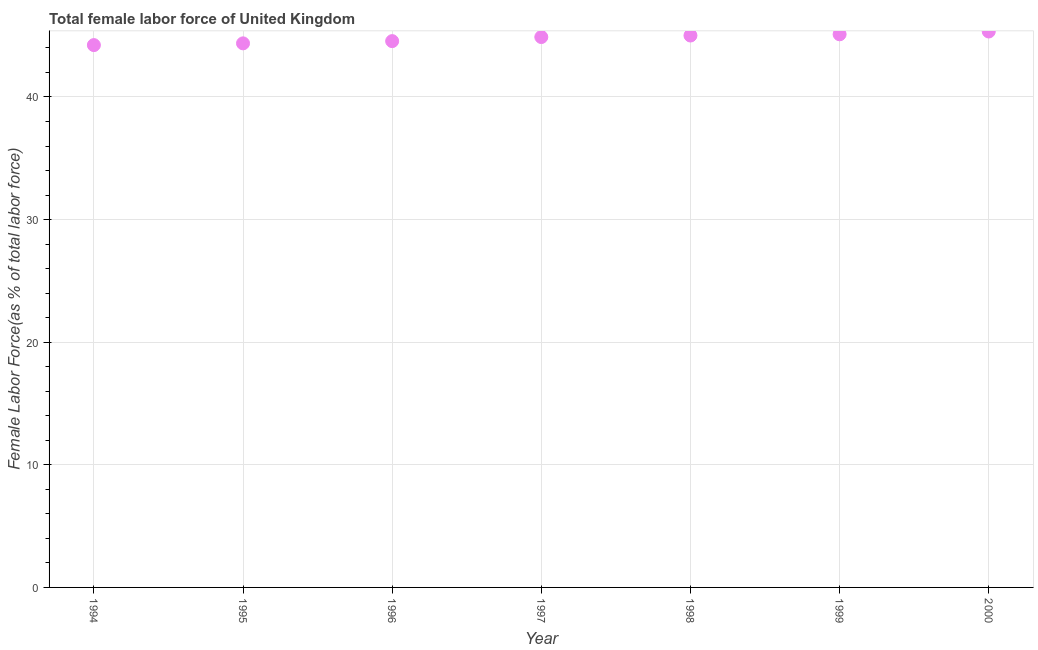What is the total female labor force in 1994?
Give a very brief answer. 44.23. Across all years, what is the maximum total female labor force?
Keep it short and to the point. 45.34. Across all years, what is the minimum total female labor force?
Give a very brief answer. 44.23. What is the sum of the total female labor force?
Provide a succinct answer. 313.52. What is the difference between the total female labor force in 1994 and 1997?
Make the answer very short. -0.66. What is the average total female labor force per year?
Offer a very short reply. 44.79. What is the median total female labor force?
Give a very brief answer. 44.89. What is the ratio of the total female labor force in 1995 to that in 2000?
Ensure brevity in your answer.  0.98. What is the difference between the highest and the second highest total female labor force?
Offer a very short reply. 0.23. Is the sum of the total female labor force in 1997 and 1999 greater than the maximum total female labor force across all years?
Your answer should be very brief. Yes. What is the difference between the highest and the lowest total female labor force?
Give a very brief answer. 1.11. In how many years, is the total female labor force greater than the average total female labor force taken over all years?
Give a very brief answer. 4. Does the total female labor force monotonically increase over the years?
Keep it short and to the point. Yes. How many dotlines are there?
Keep it short and to the point. 1. What is the difference between two consecutive major ticks on the Y-axis?
Give a very brief answer. 10. Are the values on the major ticks of Y-axis written in scientific E-notation?
Make the answer very short. No. Does the graph contain any zero values?
Offer a very short reply. No. What is the title of the graph?
Give a very brief answer. Total female labor force of United Kingdom. What is the label or title of the Y-axis?
Give a very brief answer. Female Labor Force(as % of total labor force). What is the Female Labor Force(as % of total labor force) in 1994?
Make the answer very short. 44.23. What is the Female Labor Force(as % of total labor force) in 1995?
Your response must be concise. 44.37. What is the Female Labor Force(as % of total labor force) in 1996?
Ensure brevity in your answer.  44.56. What is the Female Labor Force(as % of total labor force) in 1997?
Your answer should be very brief. 44.89. What is the Female Labor Force(as % of total labor force) in 1998?
Offer a terse response. 45.01. What is the Female Labor Force(as % of total labor force) in 1999?
Your response must be concise. 45.11. What is the Female Labor Force(as % of total labor force) in 2000?
Offer a terse response. 45.34. What is the difference between the Female Labor Force(as % of total labor force) in 1994 and 1995?
Ensure brevity in your answer.  -0.14. What is the difference between the Female Labor Force(as % of total labor force) in 1994 and 1996?
Provide a short and direct response. -0.32. What is the difference between the Female Labor Force(as % of total labor force) in 1994 and 1997?
Your response must be concise. -0.66. What is the difference between the Female Labor Force(as % of total labor force) in 1994 and 1998?
Provide a succinct answer. -0.78. What is the difference between the Female Labor Force(as % of total labor force) in 1994 and 1999?
Your answer should be compact. -0.88. What is the difference between the Female Labor Force(as % of total labor force) in 1994 and 2000?
Offer a very short reply. -1.11. What is the difference between the Female Labor Force(as % of total labor force) in 1995 and 1996?
Your answer should be very brief. -0.18. What is the difference between the Female Labor Force(as % of total labor force) in 1995 and 1997?
Provide a succinct answer. -0.51. What is the difference between the Female Labor Force(as % of total labor force) in 1995 and 1998?
Keep it short and to the point. -0.64. What is the difference between the Female Labor Force(as % of total labor force) in 1995 and 1999?
Provide a succinct answer. -0.74. What is the difference between the Female Labor Force(as % of total labor force) in 1995 and 2000?
Provide a short and direct response. -0.97. What is the difference between the Female Labor Force(as % of total labor force) in 1996 and 1997?
Provide a short and direct response. -0.33. What is the difference between the Female Labor Force(as % of total labor force) in 1996 and 1998?
Provide a short and direct response. -0.46. What is the difference between the Female Labor Force(as % of total labor force) in 1996 and 1999?
Provide a short and direct response. -0.56. What is the difference between the Female Labor Force(as % of total labor force) in 1996 and 2000?
Make the answer very short. -0.78. What is the difference between the Female Labor Force(as % of total labor force) in 1997 and 1998?
Offer a very short reply. -0.12. What is the difference between the Female Labor Force(as % of total labor force) in 1997 and 1999?
Your answer should be compact. -0.22. What is the difference between the Female Labor Force(as % of total labor force) in 1997 and 2000?
Your response must be concise. -0.45. What is the difference between the Female Labor Force(as % of total labor force) in 1998 and 1999?
Your answer should be compact. -0.1. What is the difference between the Female Labor Force(as % of total labor force) in 1998 and 2000?
Ensure brevity in your answer.  -0.33. What is the difference between the Female Labor Force(as % of total labor force) in 1999 and 2000?
Offer a terse response. -0.23. What is the ratio of the Female Labor Force(as % of total labor force) in 1994 to that in 1995?
Keep it short and to the point. 1. What is the ratio of the Female Labor Force(as % of total labor force) in 1994 to that in 1997?
Keep it short and to the point. 0.98. What is the ratio of the Female Labor Force(as % of total labor force) in 1994 to that in 1998?
Your answer should be very brief. 0.98. What is the ratio of the Female Labor Force(as % of total labor force) in 1994 to that in 2000?
Give a very brief answer. 0.98. What is the ratio of the Female Labor Force(as % of total labor force) in 1995 to that in 1997?
Provide a succinct answer. 0.99. What is the ratio of the Female Labor Force(as % of total labor force) in 1995 to that in 2000?
Your answer should be very brief. 0.98. What is the ratio of the Female Labor Force(as % of total labor force) in 1996 to that in 1998?
Make the answer very short. 0.99. What is the ratio of the Female Labor Force(as % of total labor force) in 1996 to that in 2000?
Make the answer very short. 0.98. What is the ratio of the Female Labor Force(as % of total labor force) in 1997 to that in 1998?
Keep it short and to the point. 1. What is the ratio of the Female Labor Force(as % of total labor force) in 1997 to that in 1999?
Give a very brief answer. 0.99. What is the ratio of the Female Labor Force(as % of total labor force) in 1998 to that in 1999?
Give a very brief answer. 1. What is the ratio of the Female Labor Force(as % of total labor force) in 1998 to that in 2000?
Give a very brief answer. 0.99. What is the ratio of the Female Labor Force(as % of total labor force) in 1999 to that in 2000?
Provide a short and direct response. 0.99. 